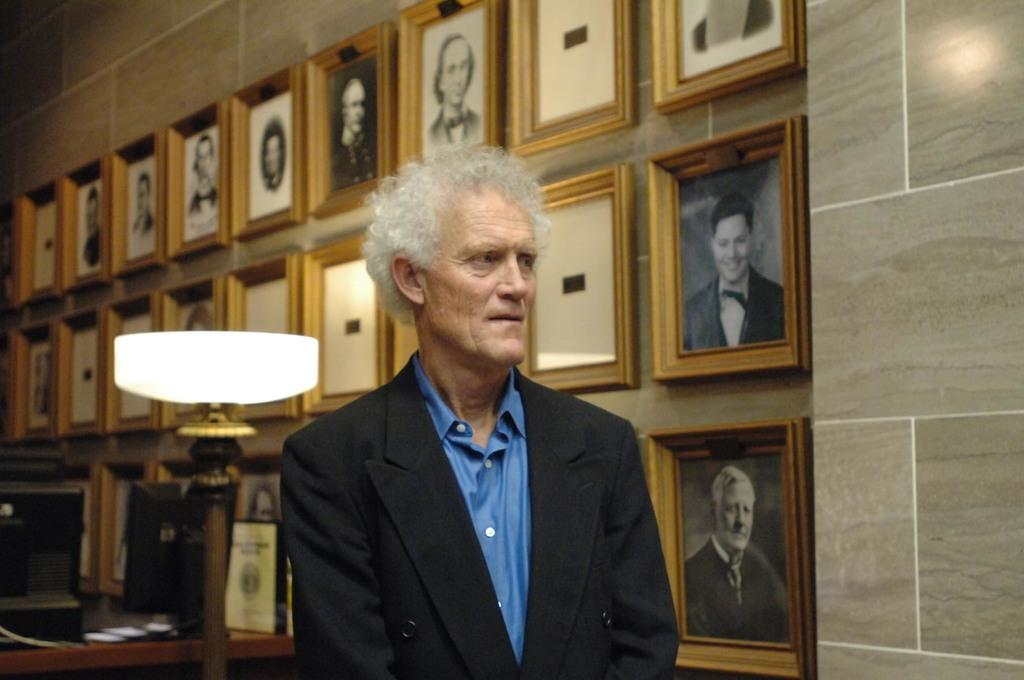What is the main subject of the image? There is a man standing in the image. What is the man wearing? The man is wearing a formal suit. What can be seen in the background of the image? There are photo frames of people on the wall in the background. How does the man account for his loss in the image? There is no indication of loss or any related context in the image, so it cannot be determined from the image. 